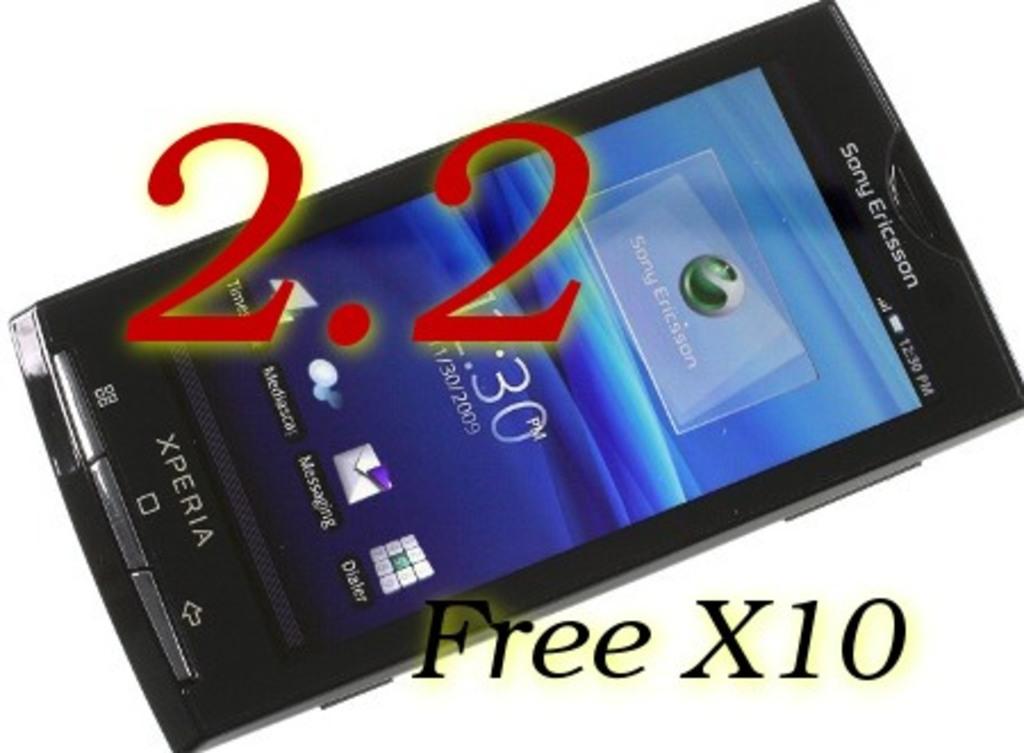What is free?
Give a very brief answer. X10. What brand of phone is this?
Ensure brevity in your answer.  Sony ericsson. 